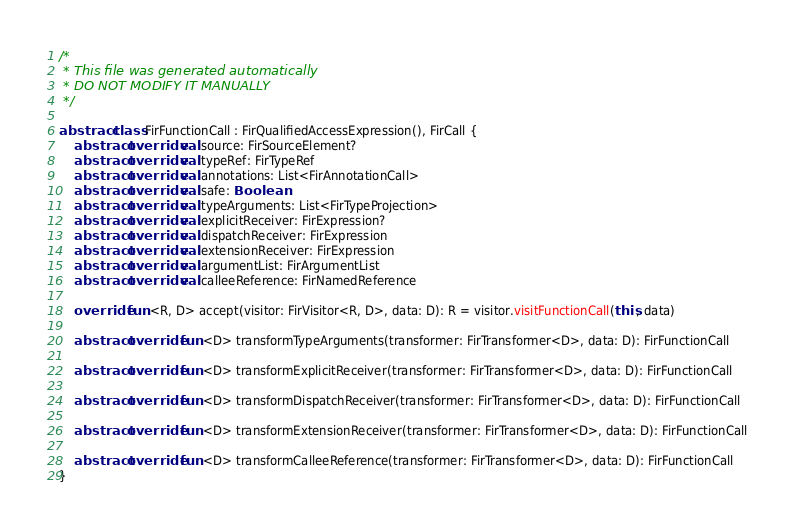Convert code to text. <code><loc_0><loc_0><loc_500><loc_500><_Kotlin_>/*
 * This file was generated automatically
 * DO NOT MODIFY IT MANUALLY
 */

abstract class FirFunctionCall : FirQualifiedAccessExpression(), FirCall {
    abstract override val source: FirSourceElement?
    abstract override val typeRef: FirTypeRef
    abstract override val annotations: List<FirAnnotationCall>
    abstract override val safe: Boolean
    abstract override val typeArguments: List<FirTypeProjection>
    abstract override val explicitReceiver: FirExpression?
    abstract override val dispatchReceiver: FirExpression
    abstract override val extensionReceiver: FirExpression
    abstract override val argumentList: FirArgumentList
    abstract override val calleeReference: FirNamedReference

    override fun <R, D> accept(visitor: FirVisitor<R, D>, data: D): R = visitor.visitFunctionCall(this, data)

    abstract override fun <D> transformTypeArguments(transformer: FirTransformer<D>, data: D): FirFunctionCall

    abstract override fun <D> transformExplicitReceiver(transformer: FirTransformer<D>, data: D): FirFunctionCall

    abstract override fun <D> transformDispatchReceiver(transformer: FirTransformer<D>, data: D): FirFunctionCall

    abstract override fun <D> transformExtensionReceiver(transformer: FirTransformer<D>, data: D): FirFunctionCall

    abstract override fun <D> transformCalleeReference(transformer: FirTransformer<D>, data: D): FirFunctionCall
}
</code> 